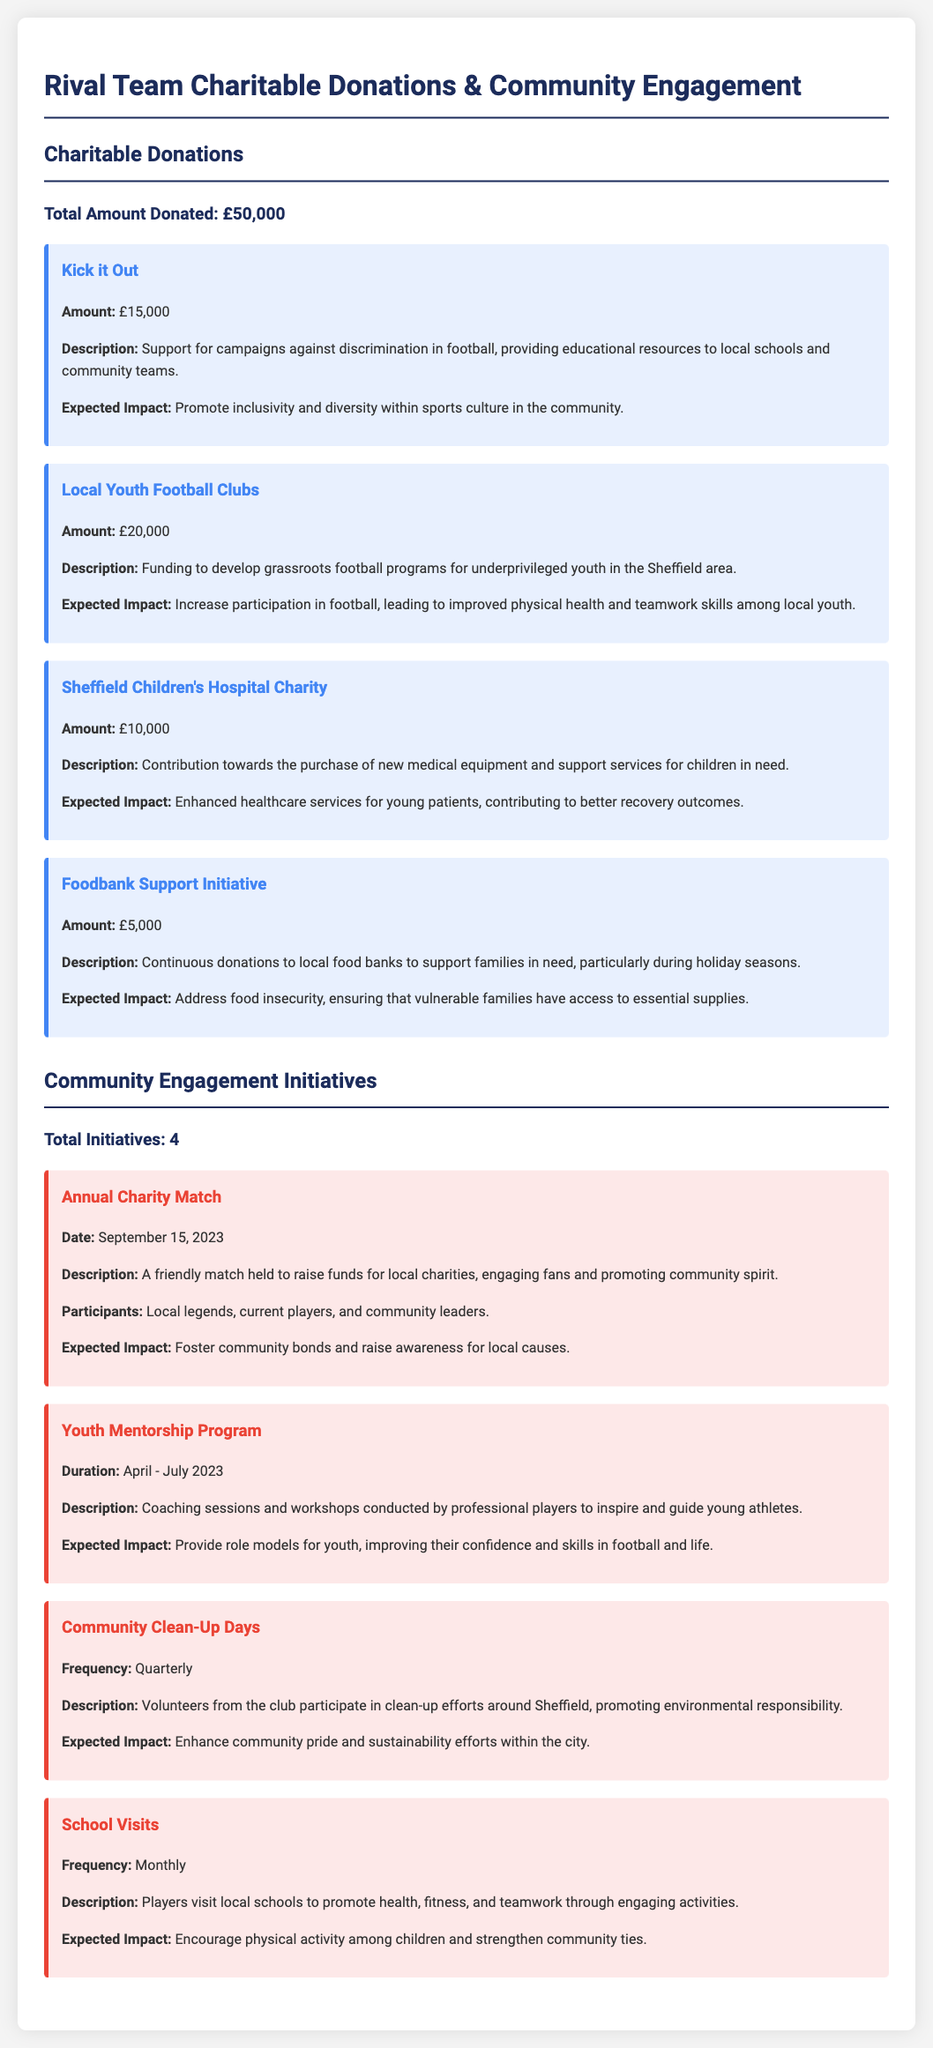What is the total amount donated? The total amount donated is stated in the document as £50,000.
Answer: £50,000 How much was donated to the Sheffield Children's Hospital Charity? The specific amount donated to this charity is detailed in the document as £10,000.
Answer: £10,000 What is one expected impact of the Kick it Out initiative? The document mentions that one expected impact is to "promote inclusivity and diversity within sports culture in the community."
Answer: Promote inclusivity and diversity When was the Annual Charity Match held? The document specifies the date for this event as September 15, 2023.
Answer: September 15, 2023 How many community engagement initiatives are listed in the document? The document states the total number of initiatives under community engagement as 4.
Answer: 4 What is the purpose of the Youth Mentorship Program? The document describes this program as providing coaching sessions and workshops to inspire and guide young athletes, connecting players to the community.
Answer: Inspire and guide young athletes What amount was allocated to the Foodbank Support Initiative? The document clearly indicates that £5,000 was dedicated to this initiative.
Answer: £5,000 What type of events occur quarterly according to the document? The document states that Community Clean-Up Days occur quarterly.
Answer: Community Clean-Up Days 